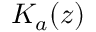Convert formula to latex. <formula><loc_0><loc_0><loc_500><loc_500>K _ { a } ( z )</formula> 